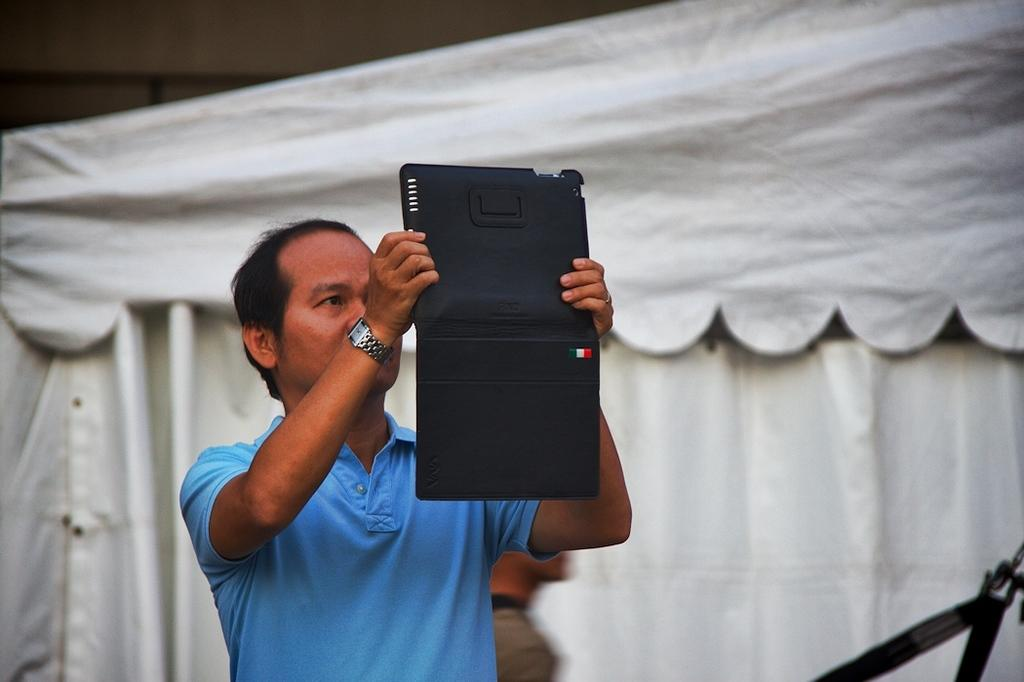What is the main subject of the image? There is a man in the image. What is the man wearing? The man is wearing a blue t-shirt. What is the man doing in the image? The man is standing. What is the man holding in the image? The man is holding a tab with a black cover. What accessory is the man wearing on his wrist? The man has a watch on his wrist. What color tint can be seen in the background of the image? There is a white color tint in the background. How many buckets can be seen in the image? There are no buckets present in the image. What type of shoe is the laborer wearing in the image? There is no laborer or shoe present in the image. 